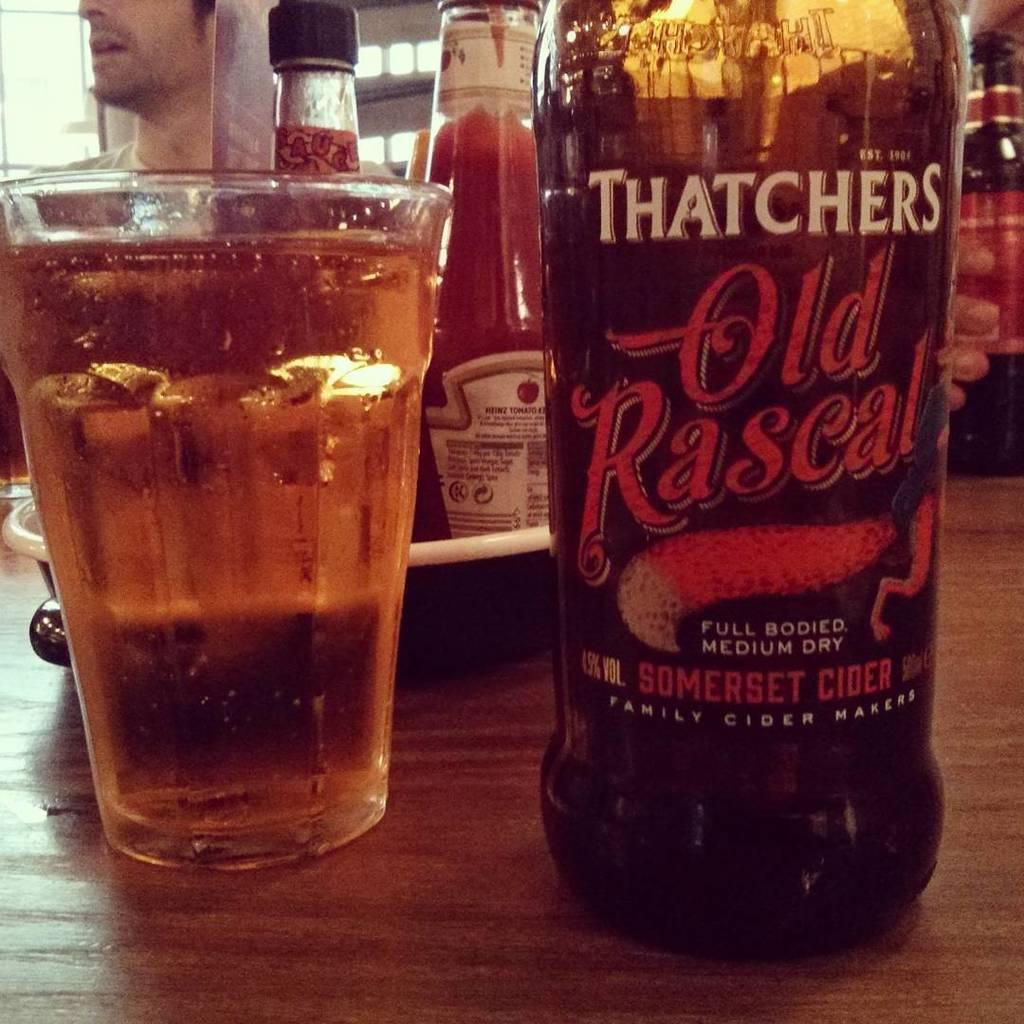How would you summarize this image in a sentence or two? In the image there is a table. On table we can see a bottle which is labelled as old rascal,a glass filled with some wine and sauce placed inside the tray and background we can see a man he is turning towards left side. 